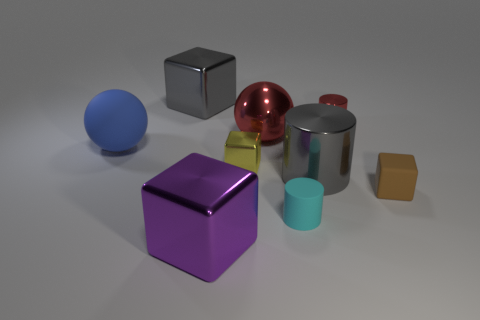Subtract all small brown rubber cubes. How many cubes are left? 3 Subtract all balls. How many objects are left? 7 Add 7 small blocks. How many small blocks exist? 9 Subtract all red cylinders. How many cylinders are left? 2 Subtract 0 brown cylinders. How many objects are left? 9 Subtract 3 cylinders. How many cylinders are left? 0 Subtract all brown blocks. Subtract all yellow spheres. How many blocks are left? 3 Subtract all red balls. How many red cubes are left? 0 Subtract all tiny red metallic cubes. Subtract all red shiny balls. How many objects are left? 8 Add 3 red metal spheres. How many red metal spheres are left? 4 